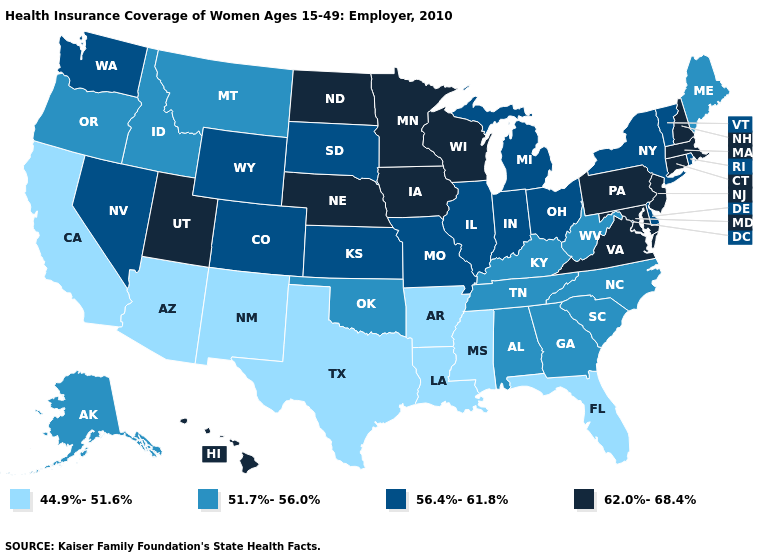Does the first symbol in the legend represent the smallest category?
Give a very brief answer. Yes. Does West Virginia have a lower value than New Jersey?
Keep it brief. Yes. Does North Carolina have the highest value in the South?
Keep it brief. No. Which states have the lowest value in the USA?
Keep it brief. Arizona, Arkansas, California, Florida, Louisiana, Mississippi, New Mexico, Texas. Name the states that have a value in the range 62.0%-68.4%?
Give a very brief answer. Connecticut, Hawaii, Iowa, Maryland, Massachusetts, Minnesota, Nebraska, New Hampshire, New Jersey, North Dakota, Pennsylvania, Utah, Virginia, Wisconsin. Which states hav the highest value in the Northeast?
Keep it brief. Connecticut, Massachusetts, New Hampshire, New Jersey, Pennsylvania. What is the lowest value in the MidWest?
Be succinct. 56.4%-61.8%. Among the states that border Delaware , which have the lowest value?
Short answer required. Maryland, New Jersey, Pennsylvania. Among the states that border Maryland , does West Virginia have the highest value?
Keep it brief. No. Does Georgia have the highest value in the USA?
Write a very short answer. No. What is the highest value in the USA?
Short answer required. 62.0%-68.4%. Name the states that have a value in the range 62.0%-68.4%?
Answer briefly. Connecticut, Hawaii, Iowa, Maryland, Massachusetts, Minnesota, Nebraska, New Hampshire, New Jersey, North Dakota, Pennsylvania, Utah, Virginia, Wisconsin. Name the states that have a value in the range 62.0%-68.4%?
Keep it brief. Connecticut, Hawaii, Iowa, Maryland, Massachusetts, Minnesota, Nebraska, New Hampshire, New Jersey, North Dakota, Pennsylvania, Utah, Virginia, Wisconsin. Does the map have missing data?
Quick response, please. No. Which states have the lowest value in the USA?
Give a very brief answer. Arizona, Arkansas, California, Florida, Louisiana, Mississippi, New Mexico, Texas. 